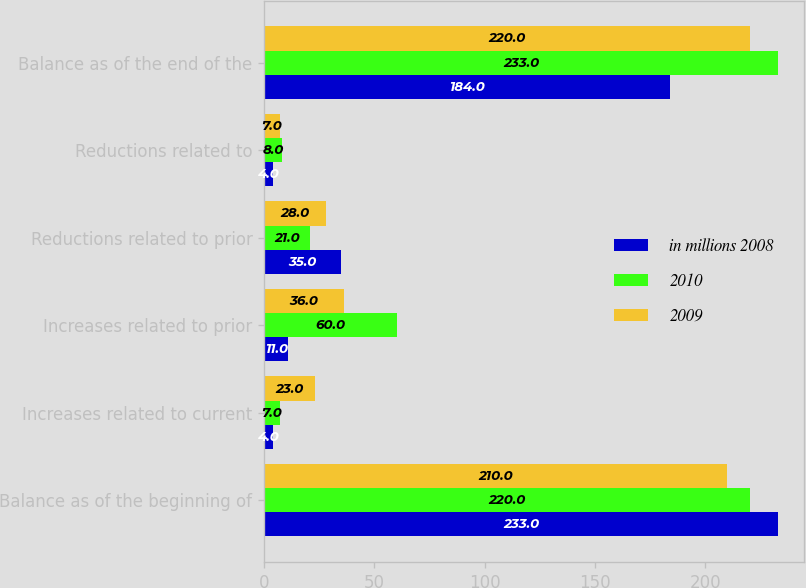Convert chart to OTSL. <chart><loc_0><loc_0><loc_500><loc_500><stacked_bar_chart><ecel><fcel>Balance as of the beginning of<fcel>Increases related to current<fcel>Increases related to prior<fcel>Reductions related to prior<fcel>Reductions related to<fcel>Balance as of the end of the<nl><fcel>in millions 2008<fcel>233<fcel>4<fcel>11<fcel>35<fcel>4<fcel>184<nl><fcel>2010<fcel>220<fcel>7<fcel>60<fcel>21<fcel>8<fcel>233<nl><fcel>2009<fcel>210<fcel>23<fcel>36<fcel>28<fcel>7<fcel>220<nl></chart> 